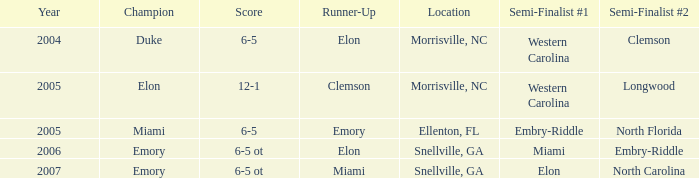Where was the final game played in 2007 Snellville, GA. Could you help me parse every detail presented in this table? {'header': ['Year', 'Champion', 'Score', 'Runner-Up', 'Location', 'Semi-Finalist #1', 'Semi-Finalist #2'], 'rows': [['2004', 'Duke', '6-5', 'Elon', 'Morrisville, NC', 'Western Carolina', 'Clemson'], ['2005', 'Elon', '12-1', 'Clemson', 'Morrisville, NC', 'Western Carolina', 'Longwood'], ['2005', 'Miami', '6-5', 'Emory', 'Ellenton, FL', 'Embry-Riddle', 'North Florida'], ['2006', 'Emory', '6-5 ot', 'Elon', 'Snellville, GA', 'Miami', 'Embry-Riddle'], ['2007', 'Emory', '6-5 ot', 'Miami', 'Snellville, GA', 'Elon', 'North Carolina']]} 